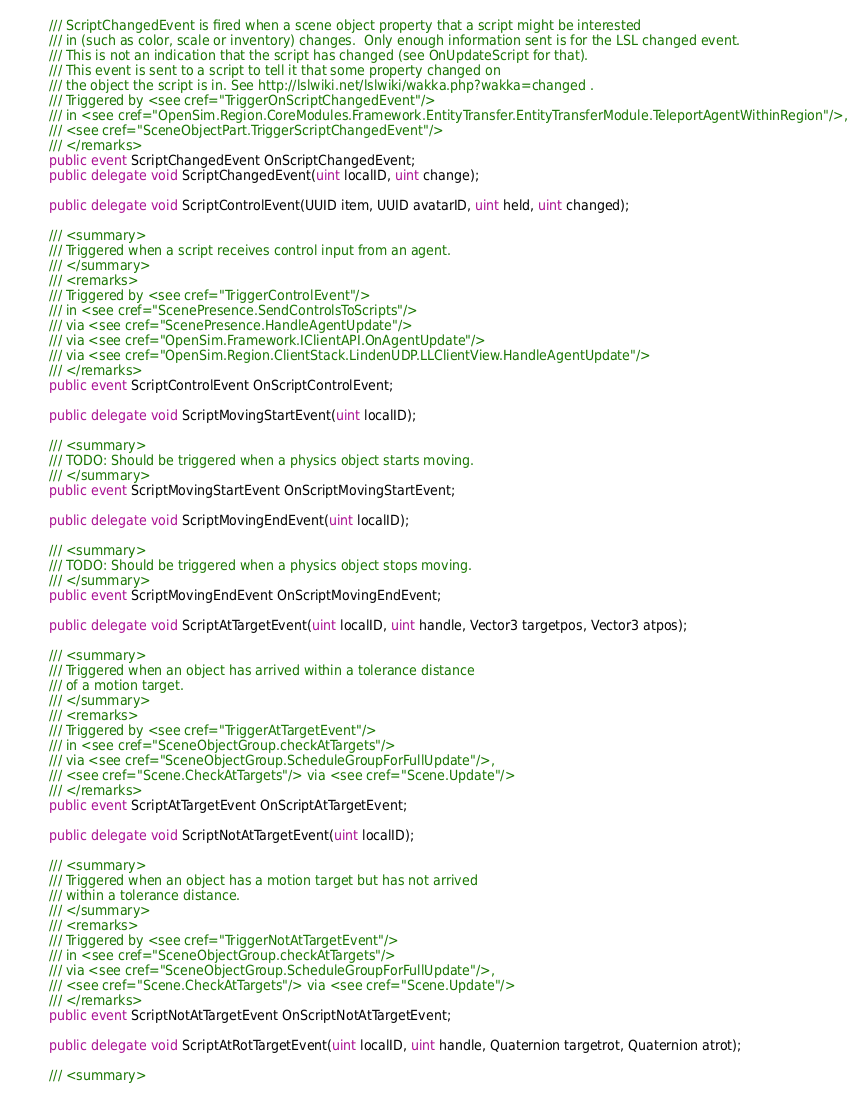<code> <loc_0><loc_0><loc_500><loc_500><_C#_>        /// ScriptChangedEvent is fired when a scene object property that a script might be interested
        /// in (such as color, scale or inventory) changes.  Only enough information sent is for the LSL changed event.
        /// This is not an indication that the script has changed (see OnUpdateScript for that).
        /// This event is sent to a script to tell it that some property changed on
        /// the object the script is in. See http://lslwiki.net/lslwiki/wakka.php?wakka=changed .
        /// Triggered by <see cref="TriggerOnScriptChangedEvent"/>
        /// in <see cref="OpenSim.Region.CoreModules.Framework.EntityTransfer.EntityTransferModule.TeleportAgentWithinRegion"/>,
        /// <see cref="SceneObjectPart.TriggerScriptChangedEvent"/>
        /// </remarks>
        public event ScriptChangedEvent OnScriptChangedEvent;
        public delegate void ScriptChangedEvent(uint localID, uint change);

        public delegate void ScriptControlEvent(UUID item, UUID avatarID, uint held, uint changed);

        /// <summary>
        /// Triggered when a script receives control input from an agent.
        /// </summary>
        /// <remarks>
        /// Triggered by <see cref="TriggerControlEvent"/>
        /// in <see cref="ScenePresence.SendControlsToScripts"/>
        /// via <see cref="ScenePresence.HandleAgentUpdate"/>
        /// via <see cref="OpenSim.Framework.IClientAPI.OnAgentUpdate"/>
        /// via <see cref="OpenSim.Region.ClientStack.LindenUDP.LLClientView.HandleAgentUpdate"/>
        /// </remarks>
        public event ScriptControlEvent OnScriptControlEvent;

        public delegate void ScriptMovingStartEvent(uint localID);

        /// <summary>
        /// TODO: Should be triggered when a physics object starts moving.
        /// </summary>
        public event ScriptMovingStartEvent OnScriptMovingStartEvent;

        public delegate void ScriptMovingEndEvent(uint localID);

        /// <summary>
        /// TODO: Should be triggered when a physics object stops moving.
        /// </summary>
        public event ScriptMovingEndEvent OnScriptMovingEndEvent;

        public delegate void ScriptAtTargetEvent(uint localID, uint handle, Vector3 targetpos, Vector3 atpos);

        /// <summary>
        /// Triggered when an object has arrived within a tolerance distance
        /// of a motion target.
        /// </summary>
        /// <remarks>
        /// Triggered by <see cref="TriggerAtTargetEvent"/>
        /// in <see cref="SceneObjectGroup.checkAtTargets"/>
        /// via <see cref="SceneObjectGroup.ScheduleGroupForFullUpdate"/>,
        /// <see cref="Scene.CheckAtTargets"/> via <see cref="Scene.Update"/>
        /// </remarks>
        public event ScriptAtTargetEvent OnScriptAtTargetEvent;

        public delegate void ScriptNotAtTargetEvent(uint localID);

        /// <summary>
        /// Triggered when an object has a motion target but has not arrived
        /// within a tolerance distance.
        /// </summary>
        /// <remarks>
        /// Triggered by <see cref="TriggerNotAtTargetEvent"/>
        /// in <see cref="SceneObjectGroup.checkAtTargets"/>
        /// via <see cref="SceneObjectGroup.ScheduleGroupForFullUpdate"/>,
        /// <see cref="Scene.CheckAtTargets"/> via <see cref="Scene.Update"/>
        /// </remarks>
        public event ScriptNotAtTargetEvent OnScriptNotAtTargetEvent;

        public delegate void ScriptAtRotTargetEvent(uint localID, uint handle, Quaternion targetrot, Quaternion atrot);

        /// <summary></code> 